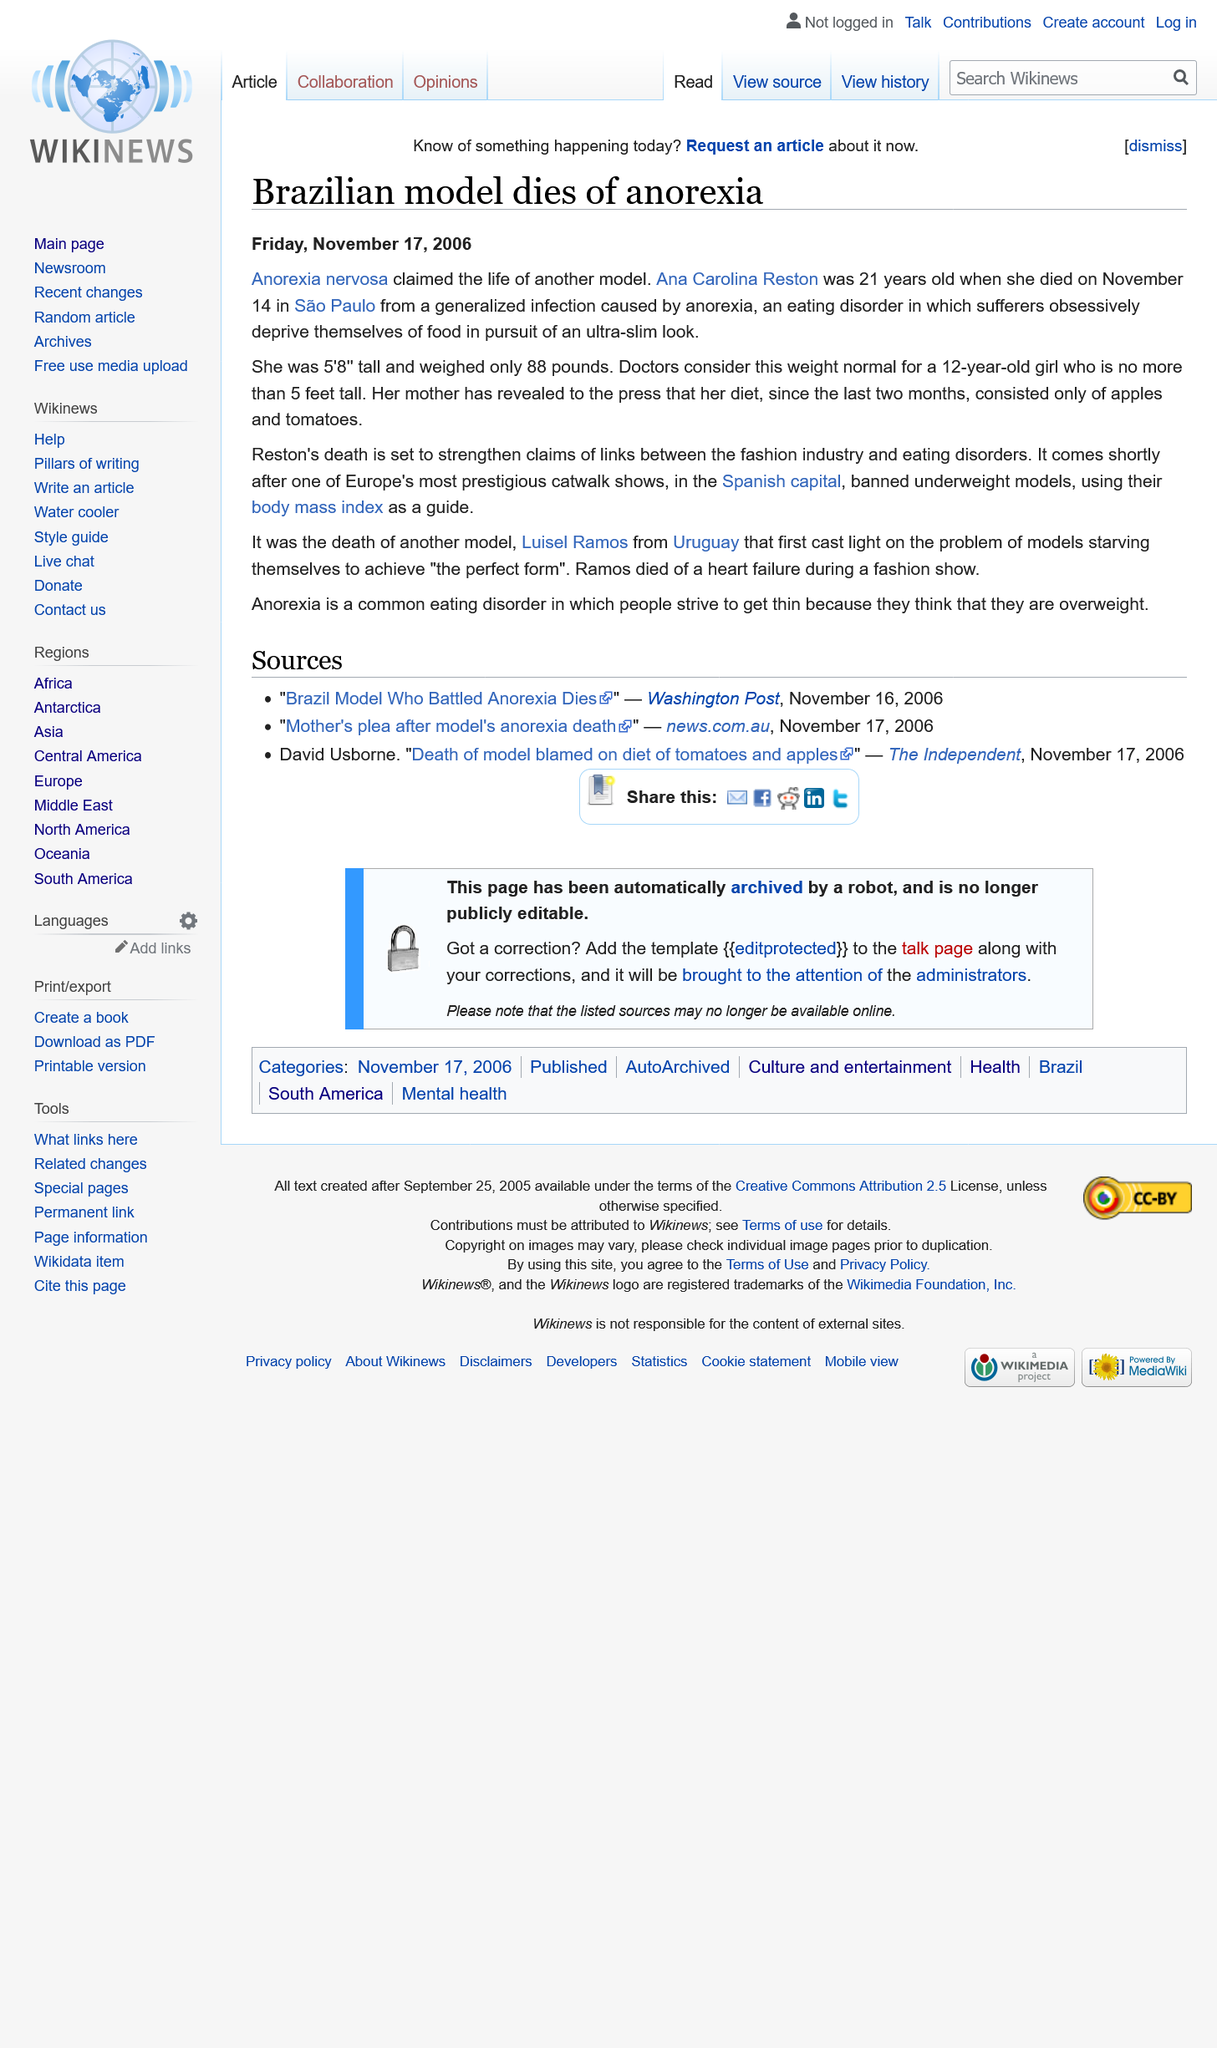Identify some key points in this picture. The article was written on the 17th of November 2006, and the model died of Anorexia. The model weighed 88 pounds. The model was 21 years old when she passed away. 